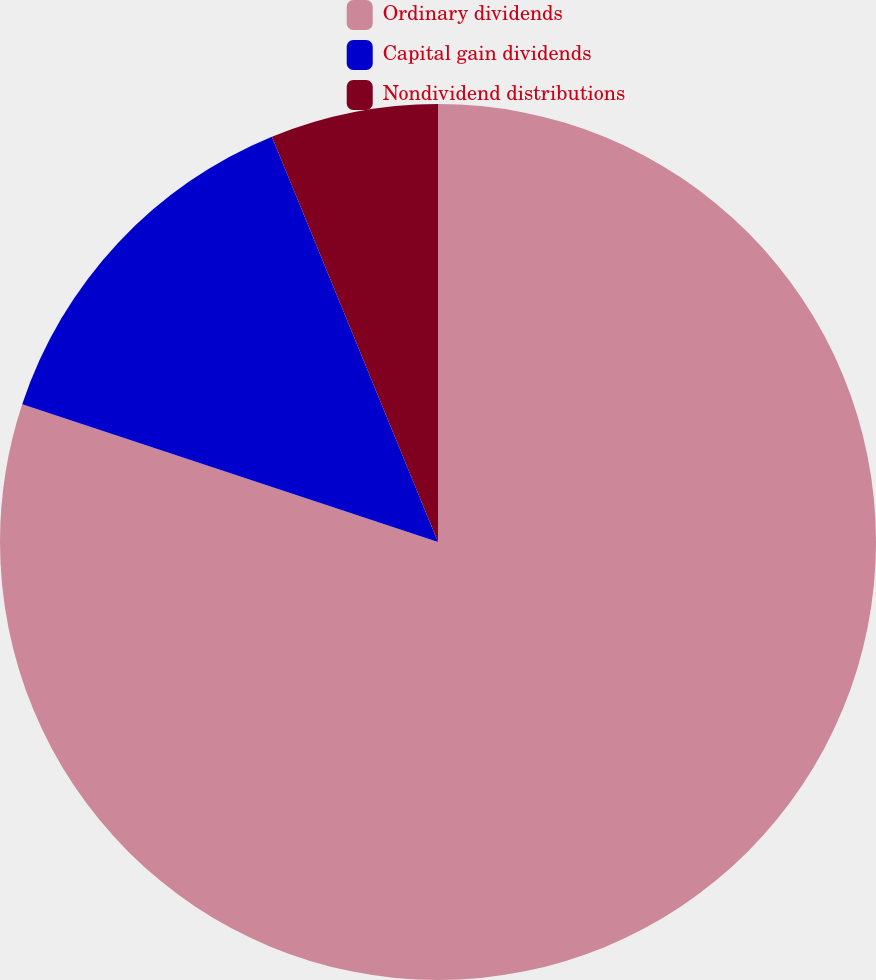Convert chart. <chart><loc_0><loc_0><loc_500><loc_500><pie_chart><fcel>Ordinary dividends<fcel>Capital gain dividends<fcel>Nondividend distributions<nl><fcel>80.09%<fcel>13.72%<fcel>6.19%<nl></chart> 